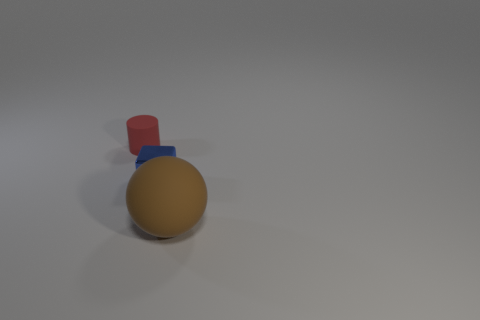Do the brown object and the tiny object on the right side of the rubber cylinder have the same material?
Your response must be concise. No. What is the shape of the small thing that is to the right of the matte thing to the left of the large brown thing?
Your response must be concise. Cube. How many tiny objects are yellow matte blocks or rubber cylinders?
Provide a succinct answer. 1. How many other large matte things are the same shape as the big object?
Give a very brief answer. 0. How many brown matte things are in front of the small red cylinder?
Offer a terse response. 1. Are there any other rubber things of the same size as the red object?
Your answer should be compact. No. The big sphere is what color?
Provide a short and direct response. Brown. Is there a blue ball?
Your answer should be compact. No. What size is the thing that is the same material as the small red cylinder?
Provide a short and direct response. Large. What is the shape of the matte object that is to the right of the tiny object that is in front of the small thing left of the tiny blue metallic cube?
Make the answer very short. Sphere. 